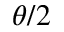<formula> <loc_0><loc_0><loc_500><loc_500>\theta / 2</formula> 